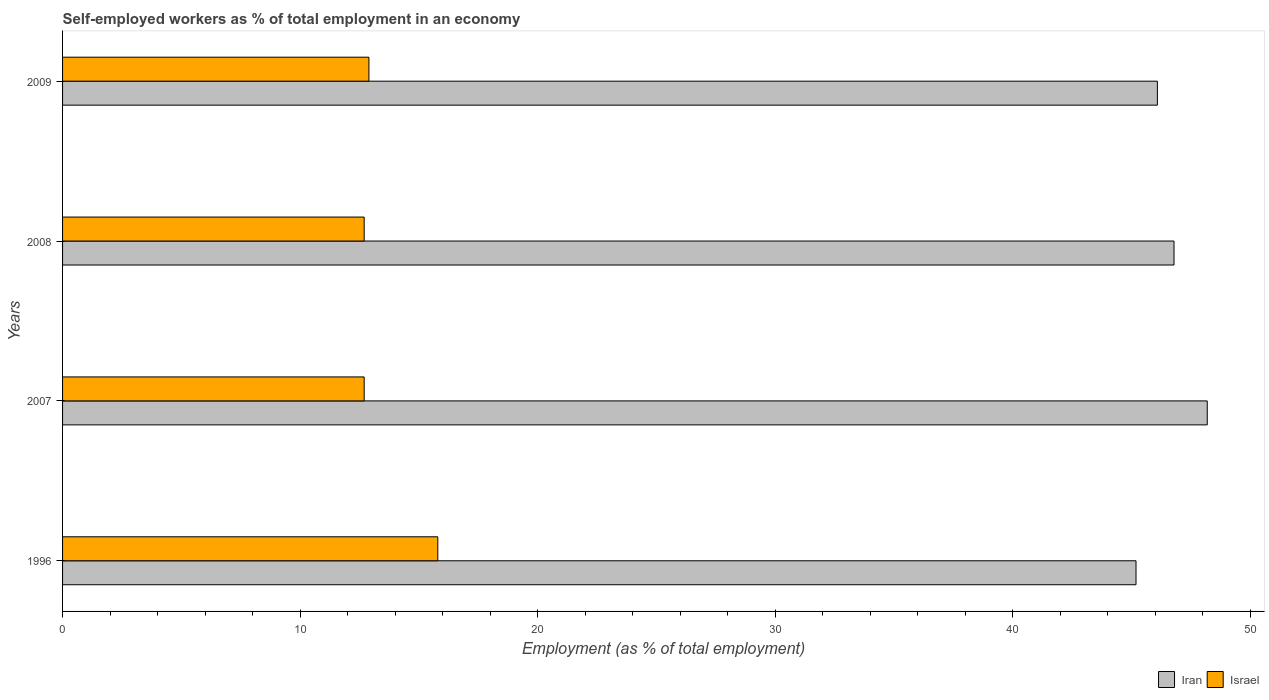How many different coloured bars are there?
Your response must be concise. 2. Are the number of bars on each tick of the Y-axis equal?
Keep it short and to the point. Yes. How many bars are there on the 3rd tick from the top?
Make the answer very short. 2. How many bars are there on the 4th tick from the bottom?
Give a very brief answer. 2. What is the label of the 3rd group of bars from the top?
Provide a succinct answer. 2007. In how many cases, is the number of bars for a given year not equal to the number of legend labels?
Offer a terse response. 0. What is the percentage of self-employed workers in Iran in 2007?
Your response must be concise. 48.2. Across all years, what is the maximum percentage of self-employed workers in Iran?
Give a very brief answer. 48.2. Across all years, what is the minimum percentage of self-employed workers in Israel?
Your answer should be very brief. 12.7. In which year was the percentage of self-employed workers in Iran maximum?
Offer a very short reply. 2007. In which year was the percentage of self-employed workers in Iran minimum?
Provide a succinct answer. 1996. What is the total percentage of self-employed workers in Iran in the graph?
Provide a short and direct response. 186.3. What is the difference between the percentage of self-employed workers in Iran in 2008 and that in 2009?
Your answer should be compact. 0.7. What is the difference between the percentage of self-employed workers in Iran in 2009 and the percentage of self-employed workers in Israel in 2007?
Ensure brevity in your answer.  33.4. What is the average percentage of self-employed workers in Iran per year?
Keep it short and to the point. 46.57. In the year 2008, what is the difference between the percentage of self-employed workers in Iran and percentage of self-employed workers in Israel?
Make the answer very short. 34.1. In how many years, is the percentage of self-employed workers in Iran greater than 32 %?
Your answer should be very brief. 4. What is the ratio of the percentage of self-employed workers in Iran in 2007 to that in 2008?
Provide a succinct answer. 1.03. Is the difference between the percentage of self-employed workers in Iran in 1996 and 2009 greater than the difference between the percentage of self-employed workers in Israel in 1996 and 2009?
Keep it short and to the point. No. What is the difference between the highest and the second highest percentage of self-employed workers in Iran?
Your response must be concise. 1.4. What is the difference between the highest and the lowest percentage of self-employed workers in Iran?
Ensure brevity in your answer.  3. In how many years, is the percentage of self-employed workers in Iran greater than the average percentage of self-employed workers in Iran taken over all years?
Your answer should be very brief. 2. What does the 2nd bar from the top in 2007 represents?
Your response must be concise. Iran. What does the 1st bar from the bottom in 2008 represents?
Provide a short and direct response. Iran. How many bars are there?
Provide a short and direct response. 8. Are all the bars in the graph horizontal?
Provide a short and direct response. Yes. What is the difference between two consecutive major ticks on the X-axis?
Provide a succinct answer. 10. How many legend labels are there?
Ensure brevity in your answer.  2. What is the title of the graph?
Your answer should be compact. Self-employed workers as % of total employment in an economy. What is the label or title of the X-axis?
Provide a succinct answer. Employment (as % of total employment). What is the Employment (as % of total employment) of Iran in 1996?
Your response must be concise. 45.2. What is the Employment (as % of total employment) in Israel in 1996?
Ensure brevity in your answer.  15.8. What is the Employment (as % of total employment) of Iran in 2007?
Keep it short and to the point. 48.2. What is the Employment (as % of total employment) in Israel in 2007?
Ensure brevity in your answer.  12.7. What is the Employment (as % of total employment) in Iran in 2008?
Your answer should be compact. 46.8. What is the Employment (as % of total employment) in Israel in 2008?
Ensure brevity in your answer.  12.7. What is the Employment (as % of total employment) of Iran in 2009?
Your answer should be very brief. 46.1. What is the Employment (as % of total employment) in Israel in 2009?
Offer a terse response. 12.9. Across all years, what is the maximum Employment (as % of total employment) in Iran?
Offer a very short reply. 48.2. Across all years, what is the maximum Employment (as % of total employment) of Israel?
Ensure brevity in your answer.  15.8. Across all years, what is the minimum Employment (as % of total employment) in Iran?
Ensure brevity in your answer.  45.2. Across all years, what is the minimum Employment (as % of total employment) in Israel?
Your answer should be very brief. 12.7. What is the total Employment (as % of total employment) in Iran in the graph?
Provide a succinct answer. 186.3. What is the total Employment (as % of total employment) of Israel in the graph?
Provide a short and direct response. 54.1. What is the difference between the Employment (as % of total employment) of Iran in 1996 and that in 2009?
Give a very brief answer. -0.9. What is the difference between the Employment (as % of total employment) in Israel in 1996 and that in 2009?
Make the answer very short. 2.9. What is the difference between the Employment (as % of total employment) in Iran in 2007 and that in 2008?
Offer a terse response. 1.4. What is the difference between the Employment (as % of total employment) in Israel in 2007 and that in 2009?
Make the answer very short. -0.2. What is the difference between the Employment (as % of total employment) of Iran in 2008 and that in 2009?
Your answer should be compact. 0.7. What is the difference between the Employment (as % of total employment) in Iran in 1996 and the Employment (as % of total employment) in Israel in 2007?
Offer a terse response. 32.5. What is the difference between the Employment (as % of total employment) of Iran in 1996 and the Employment (as % of total employment) of Israel in 2008?
Your answer should be very brief. 32.5. What is the difference between the Employment (as % of total employment) in Iran in 1996 and the Employment (as % of total employment) in Israel in 2009?
Keep it short and to the point. 32.3. What is the difference between the Employment (as % of total employment) of Iran in 2007 and the Employment (as % of total employment) of Israel in 2008?
Give a very brief answer. 35.5. What is the difference between the Employment (as % of total employment) in Iran in 2007 and the Employment (as % of total employment) in Israel in 2009?
Your answer should be very brief. 35.3. What is the difference between the Employment (as % of total employment) of Iran in 2008 and the Employment (as % of total employment) of Israel in 2009?
Keep it short and to the point. 33.9. What is the average Employment (as % of total employment) of Iran per year?
Offer a terse response. 46.58. What is the average Employment (as % of total employment) in Israel per year?
Your answer should be compact. 13.53. In the year 1996, what is the difference between the Employment (as % of total employment) in Iran and Employment (as % of total employment) in Israel?
Make the answer very short. 29.4. In the year 2007, what is the difference between the Employment (as % of total employment) of Iran and Employment (as % of total employment) of Israel?
Keep it short and to the point. 35.5. In the year 2008, what is the difference between the Employment (as % of total employment) of Iran and Employment (as % of total employment) of Israel?
Offer a terse response. 34.1. In the year 2009, what is the difference between the Employment (as % of total employment) of Iran and Employment (as % of total employment) of Israel?
Your response must be concise. 33.2. What is the ratio of the Employment (as % of total employment) of Iran in 1996 to that in 2007?
Give a very brief answer. 0.94. What is the ratio of the Employment (as % of total employment) of Israel in 1996 to that in 2007?
Keep it short and to the point. 1.24. What is the ratio of the Employment (as % of total employment) in Iran in 1996 to that in 2008?
Provide a short and direct response. 0.97. What is the ratio of the Employment (as % of total employment) of Israel in 1996 to that in 2008?
Keep it short and to the point. 1.24. What is the ratio of the Employment (as % of total employment) of Iran in 1996 to that in 2009?
Keep it short and to the point. 0.98. What is the ratio of the Employment (as % of total employment) in Israel in 1996 to that in 2009?
Your answer should be very brief. 1.22. What is the ratio of the Employment (as % of total employment) in Iran in 2007 to that in 2008?
Keep it short and to the point. 1.03. What is the ratio of the Employment (as % of total employment) of Israel in 2007 to that in 2008?
Your answer should be very brief. 1. What is the ratio of the Employment (as % of total employment) in Iran in 2007 to that in 2009?
Your answer should be very brief. 1.05. What is the ratio of the Employment (as % of total employment) in Israel in 2007 to that in 2009?
Your answer should be very brief. 0.98. What is the ratio of the Employment (as % of total employment) of Iran in 2008 to that in 2009?
Provide a short and direct response. 1.02. What is the ratio of the Employment (as % of total employment) of Israel in 2008 to that in 2009?
Provide a short and direct response. 0.98. What is the difference between the highest and the second highest Employment (as % of total employment) in Iran?
Give a very brief answer. 1.4. What is the difference between the highest and the lowest Employment (as % of total employment) in Iran?
Offer a terse response. 3. What is the difference between the highest and the lowest Employment (as % of total employment) of Israel?
Give a very brief answer. 3.1. 